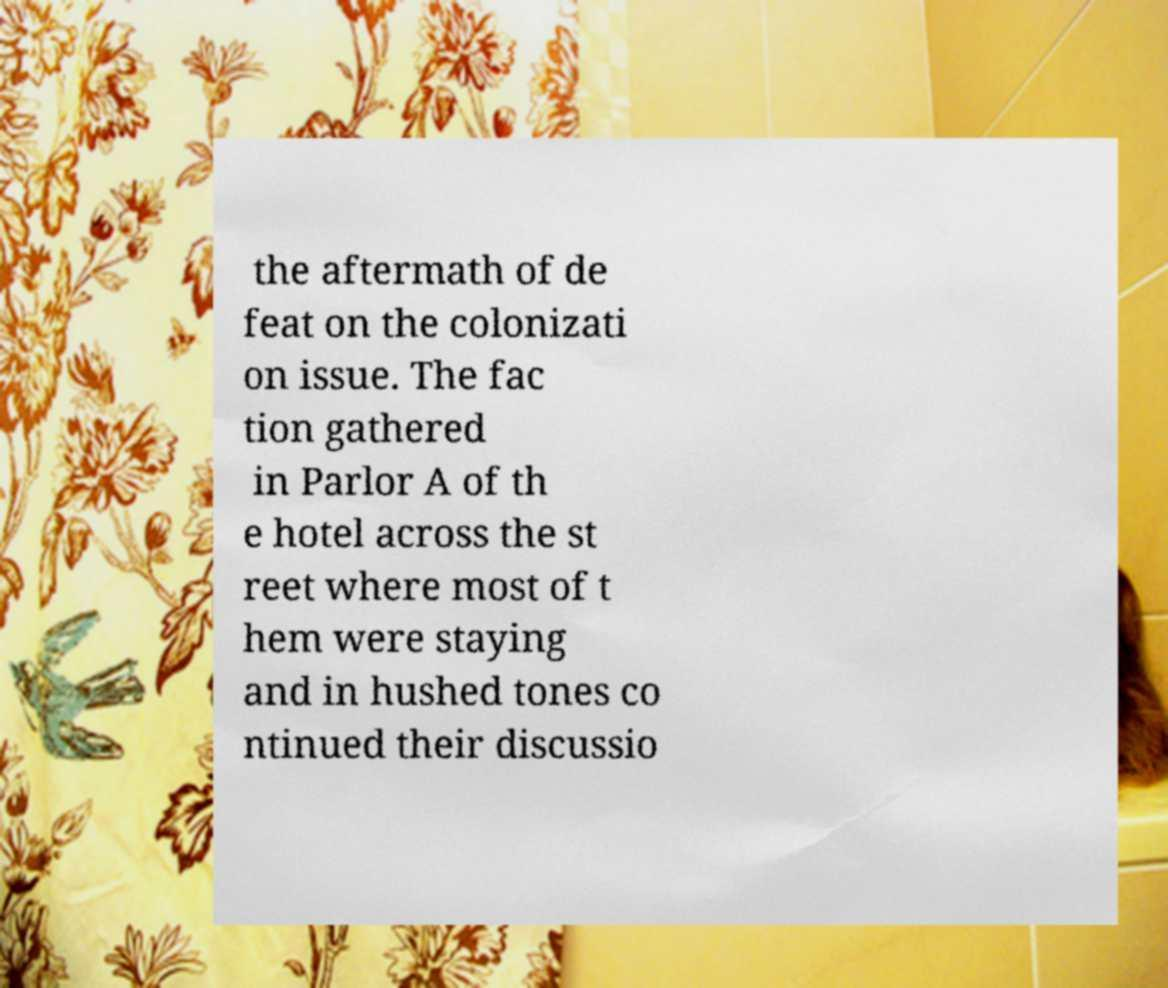Please read and relay the text visible in this image. What does it say? the aftermath of de feat on the colonizati on issue. The fac tion gathered in Parlor A of th e hotel across the st reet where most of t hem were staying and in hushed tones co ntinued their discussio 